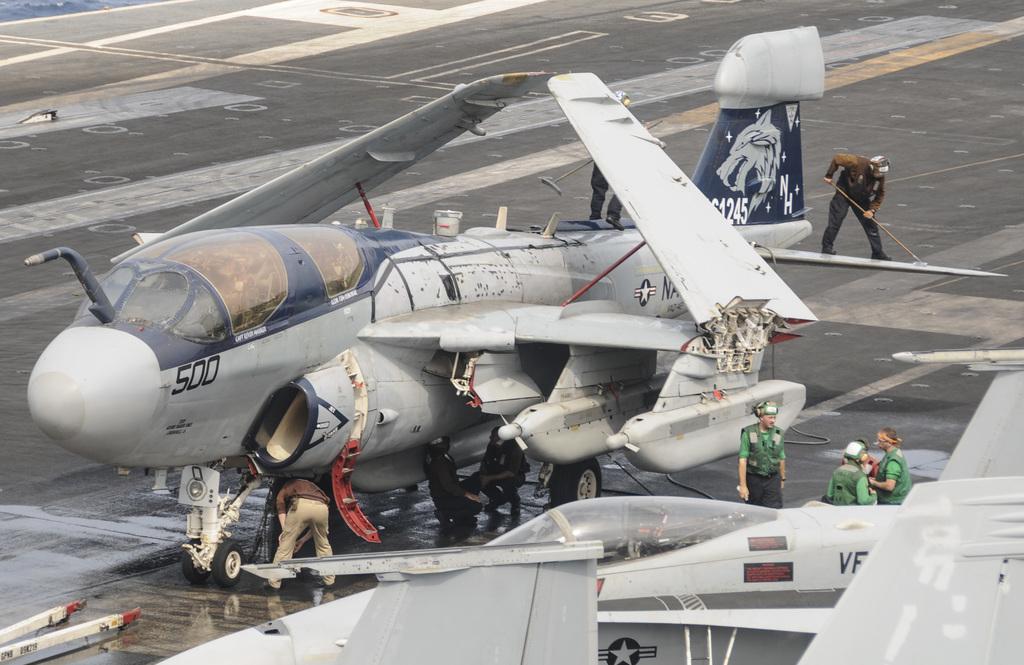What is the number on the nose?
Keep it short and to the point. 500. This is aroplan?
Your response must be concise. Answering does not require reading text in the image. 